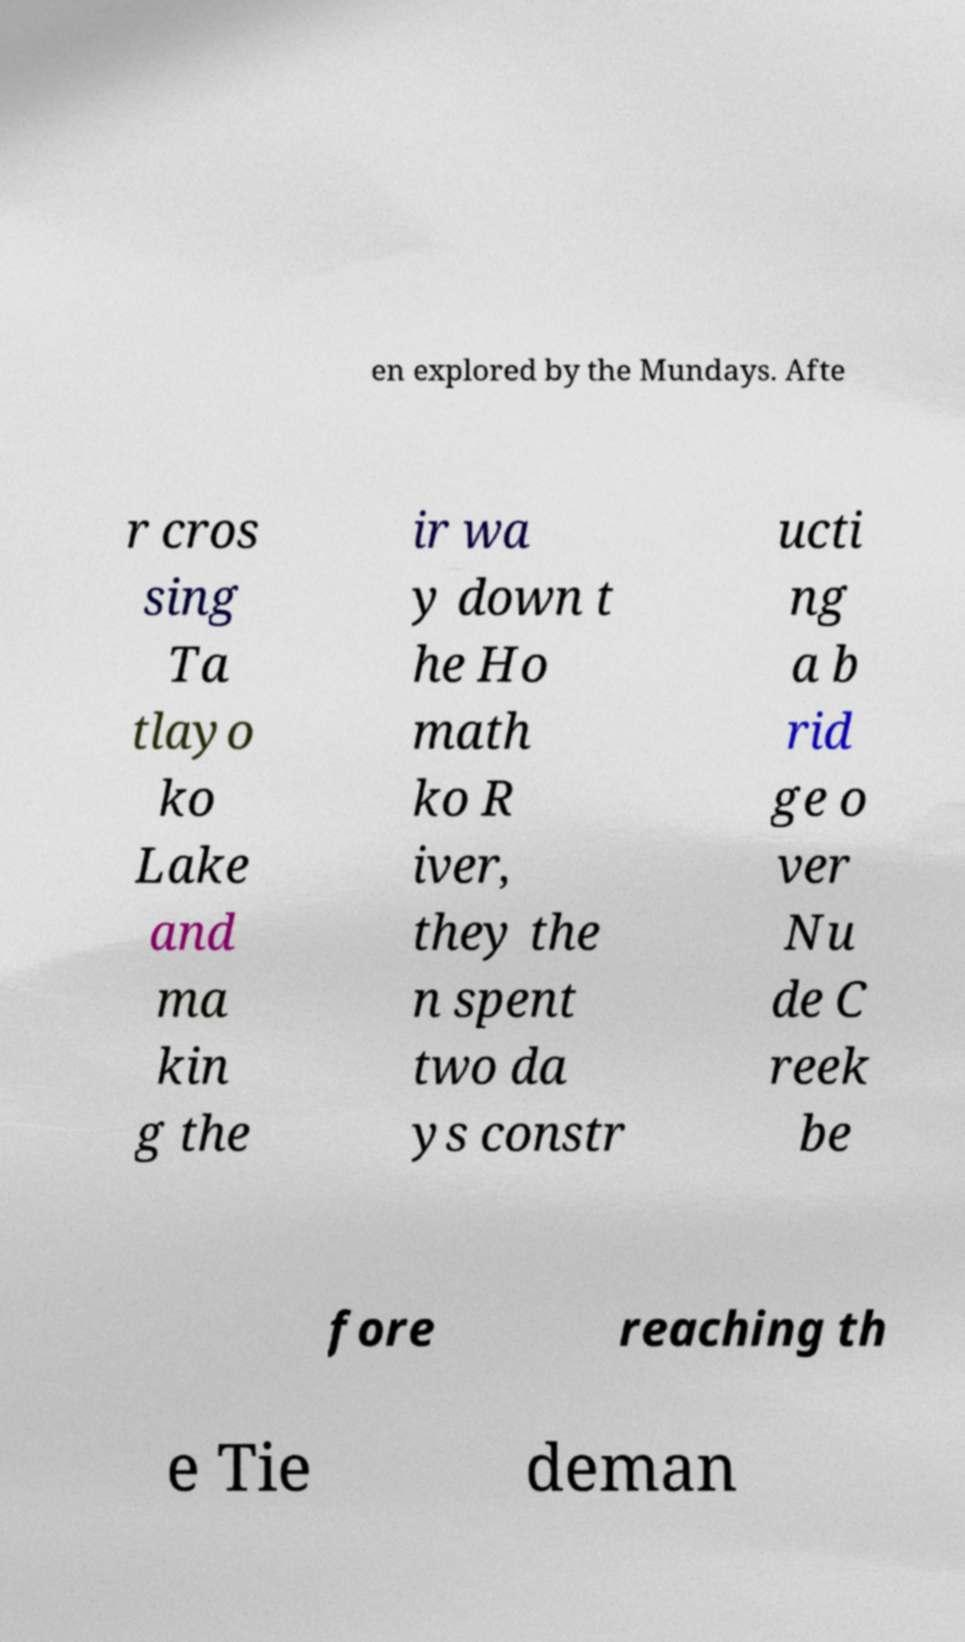Please identify and transcribe the text found in this image. en explored by the Mundays. Afte r cros sing Ta tlayo ko Lake and ma kin g the ir wa y down t he Ho math ko R iver, they the n spent two da ys constr ucti ng a b rid ge o ver Nu de C reek be fore reaching th e Tie deman 